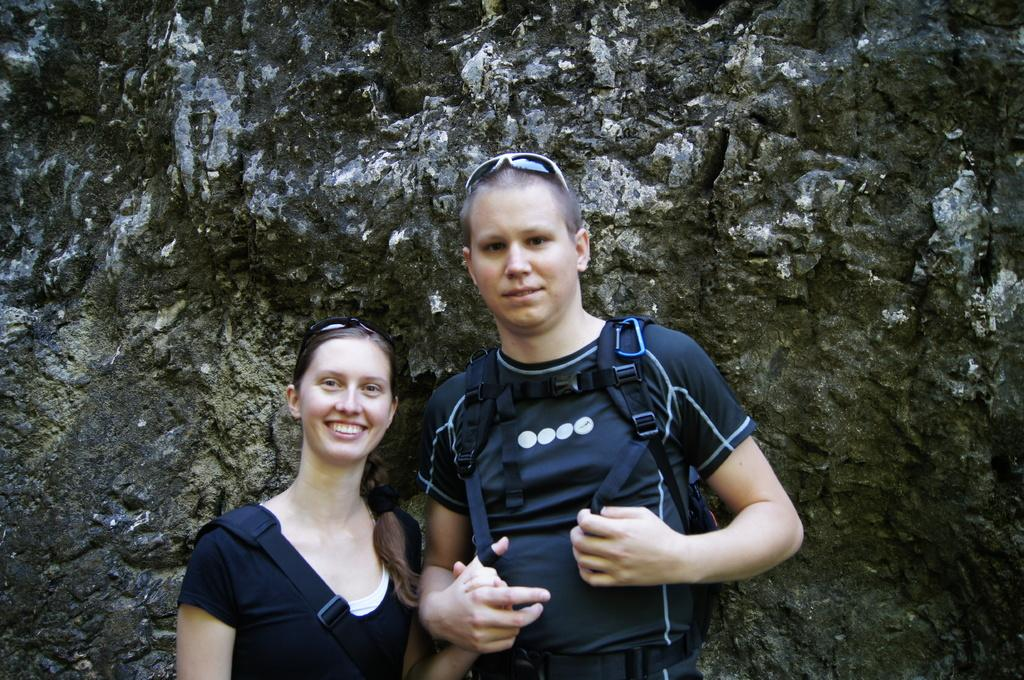How many people are in the image? There are two persons in the image. What are the people in the image doing? Both persons are standing and smiling. Can you describe any accessories or items the people are carrying? One person on the right side is carrying a backpack. What type of ice can be seen melting on the ground in the image? There is no ice present in the image; both persons are standing and smiling. 